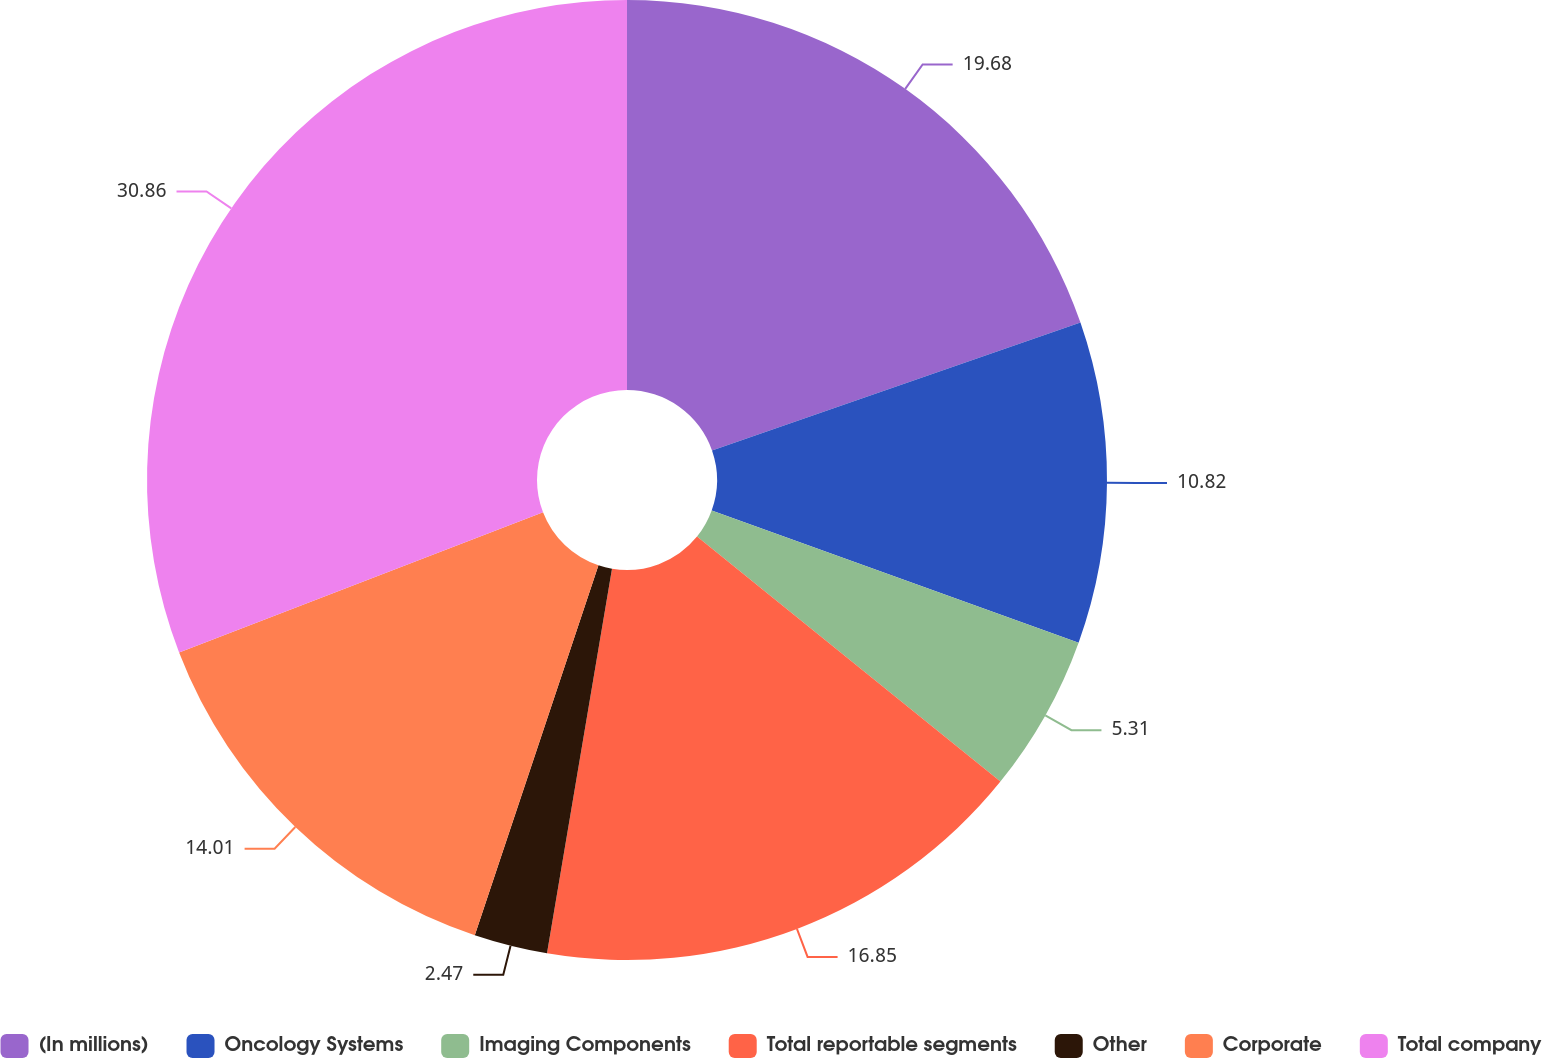Convert chart to OTSL. <chart><loc_0><loc_0><loc_500><loc_500><pie_chart><fcel>(In millions)<fcel>Oncology Systems<fcel>Imaging Components<fcel>Total reportable segments<fcel>Other<fcel>Corporate<fcel>Total company<nl><fcel>19.68%<fcel>10.82%<fcel>5.31%<fcel>16.85%<fcel>2.47%<fcel>14.01%<fcel>30.85%<nl></chart> 